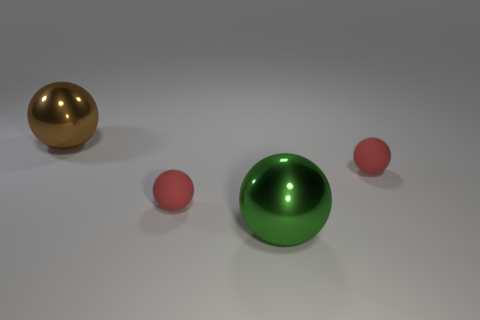Subtract all green balls. How many balls are left? 3 Subtract all cyan spheres. Subtract all cyan cylinders. How many spheres are left? 4 Add 2 large brown spheres. How many objects exist? 6 Add 3 yellow blocks. How many yellow blocks exist? 3 Subtract 0 green cylinders. How many objects are left? 4 Subtract all matte things. Subtract all green metal objects. How many objects are left? 1 Add 2 tiny spheres. How many tiny spheres are left? 4 